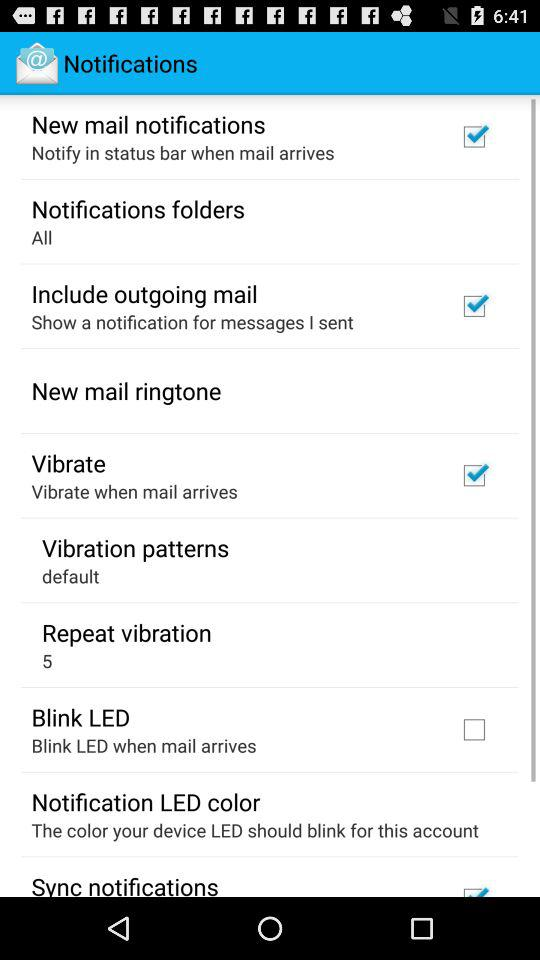What's the current setting for the vibration patterns? The current setting for the vibration patterns is "default". 